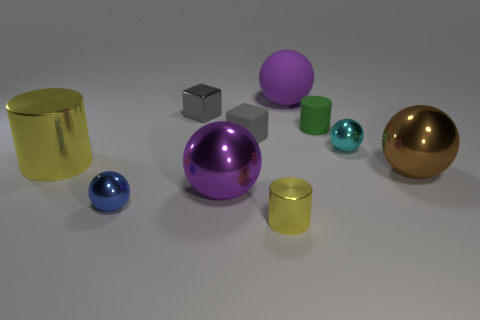Subtract all rubber spheres. How many spheres are left? 4 Subtract all blue spheres. How many yellow cylinders are left? 2 Subtract all blue balls. How many balls are left? 4 Subtract all cylinders. How many objects are left? 7 Subtract all blue balls. Subtract all green cylinders. How many balls are left? 4 Add 5 tiny gray rubber objects. How many tiny gray rubber objects exist? 6 Subtract 0 red cylinders. How many objects are left? 10 Subtract all gray rubber cubes. Subtract all small yellow metallic things. How many objects are left? 8 Add 2 yellow things. How many yellow things are left? 4 